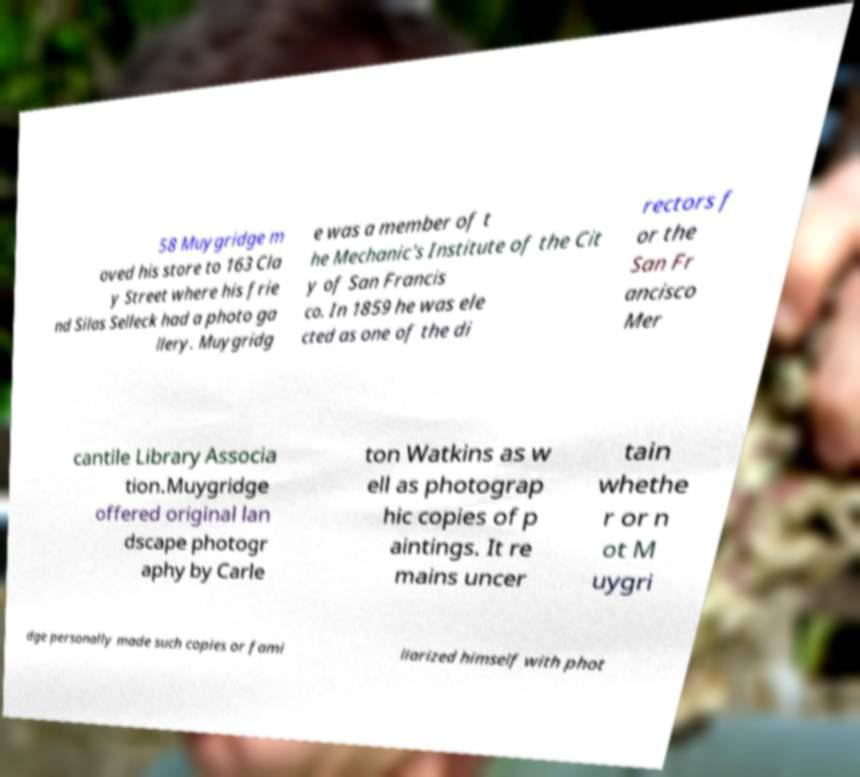Please identify and transcribe the text found in this image. 58 Muygridge m oved his store to 163 Cla y Street where his frie nd Silas Selleck had a photo ga llery. Muygridg e was a member of t he Mechanic's Institute of the Cit y of San Francis co. In 1859 he was ele cted as one of the di rectors f or the San Fr ancisco Mer cantile Library Associa tion.Muygridge offered original lan dscape photogr aphy by Carle ton Watkins as w ell as photograp hic copies of p aintings. It re mains uncer tain whethe r or n ot M uygri dge personally made such copies or fami liarized himself with phot 